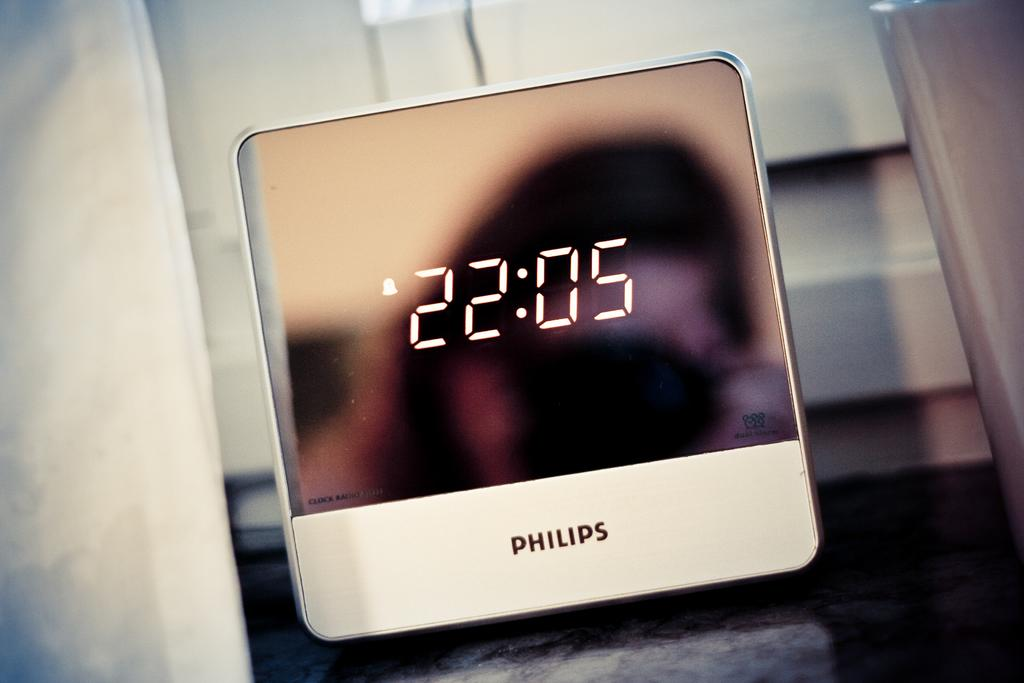Provide a one-sentence caption for the provided image. A sleek white Philips alarm clock shows the time 22:05. 